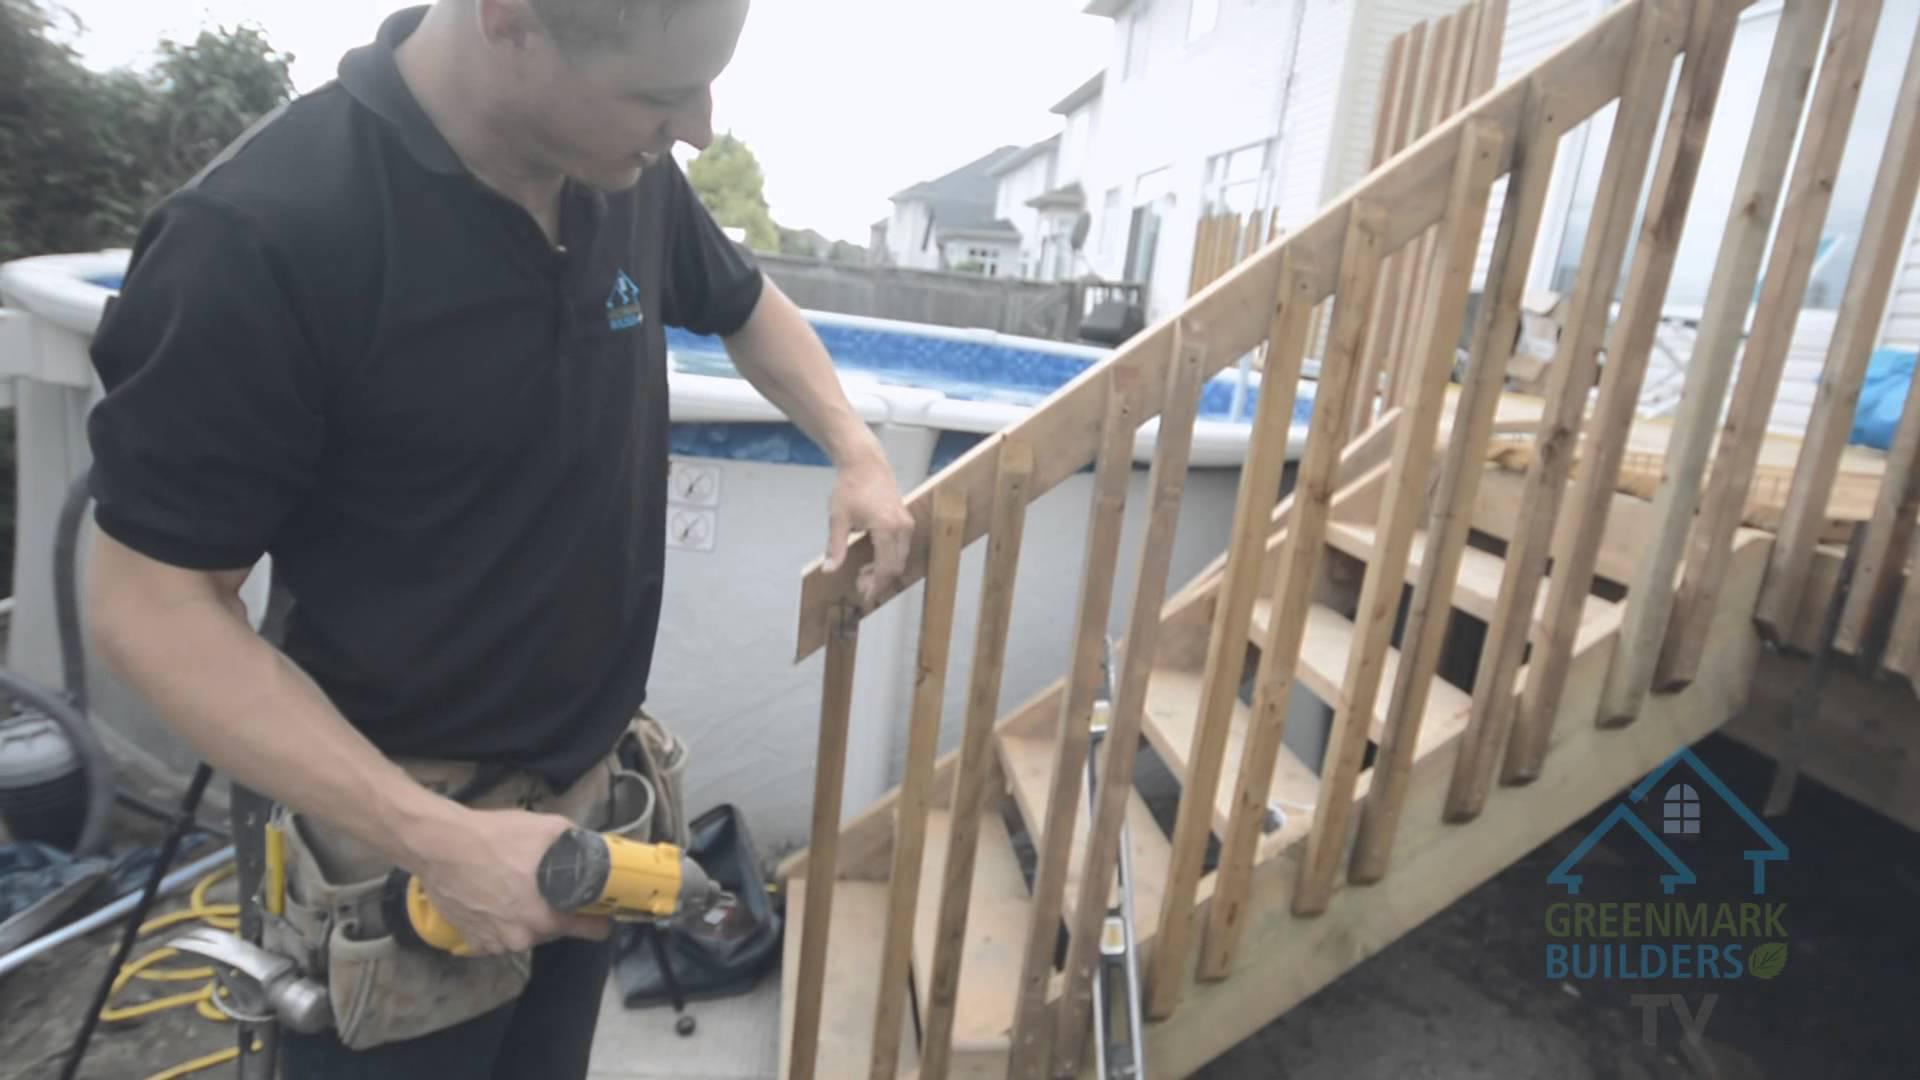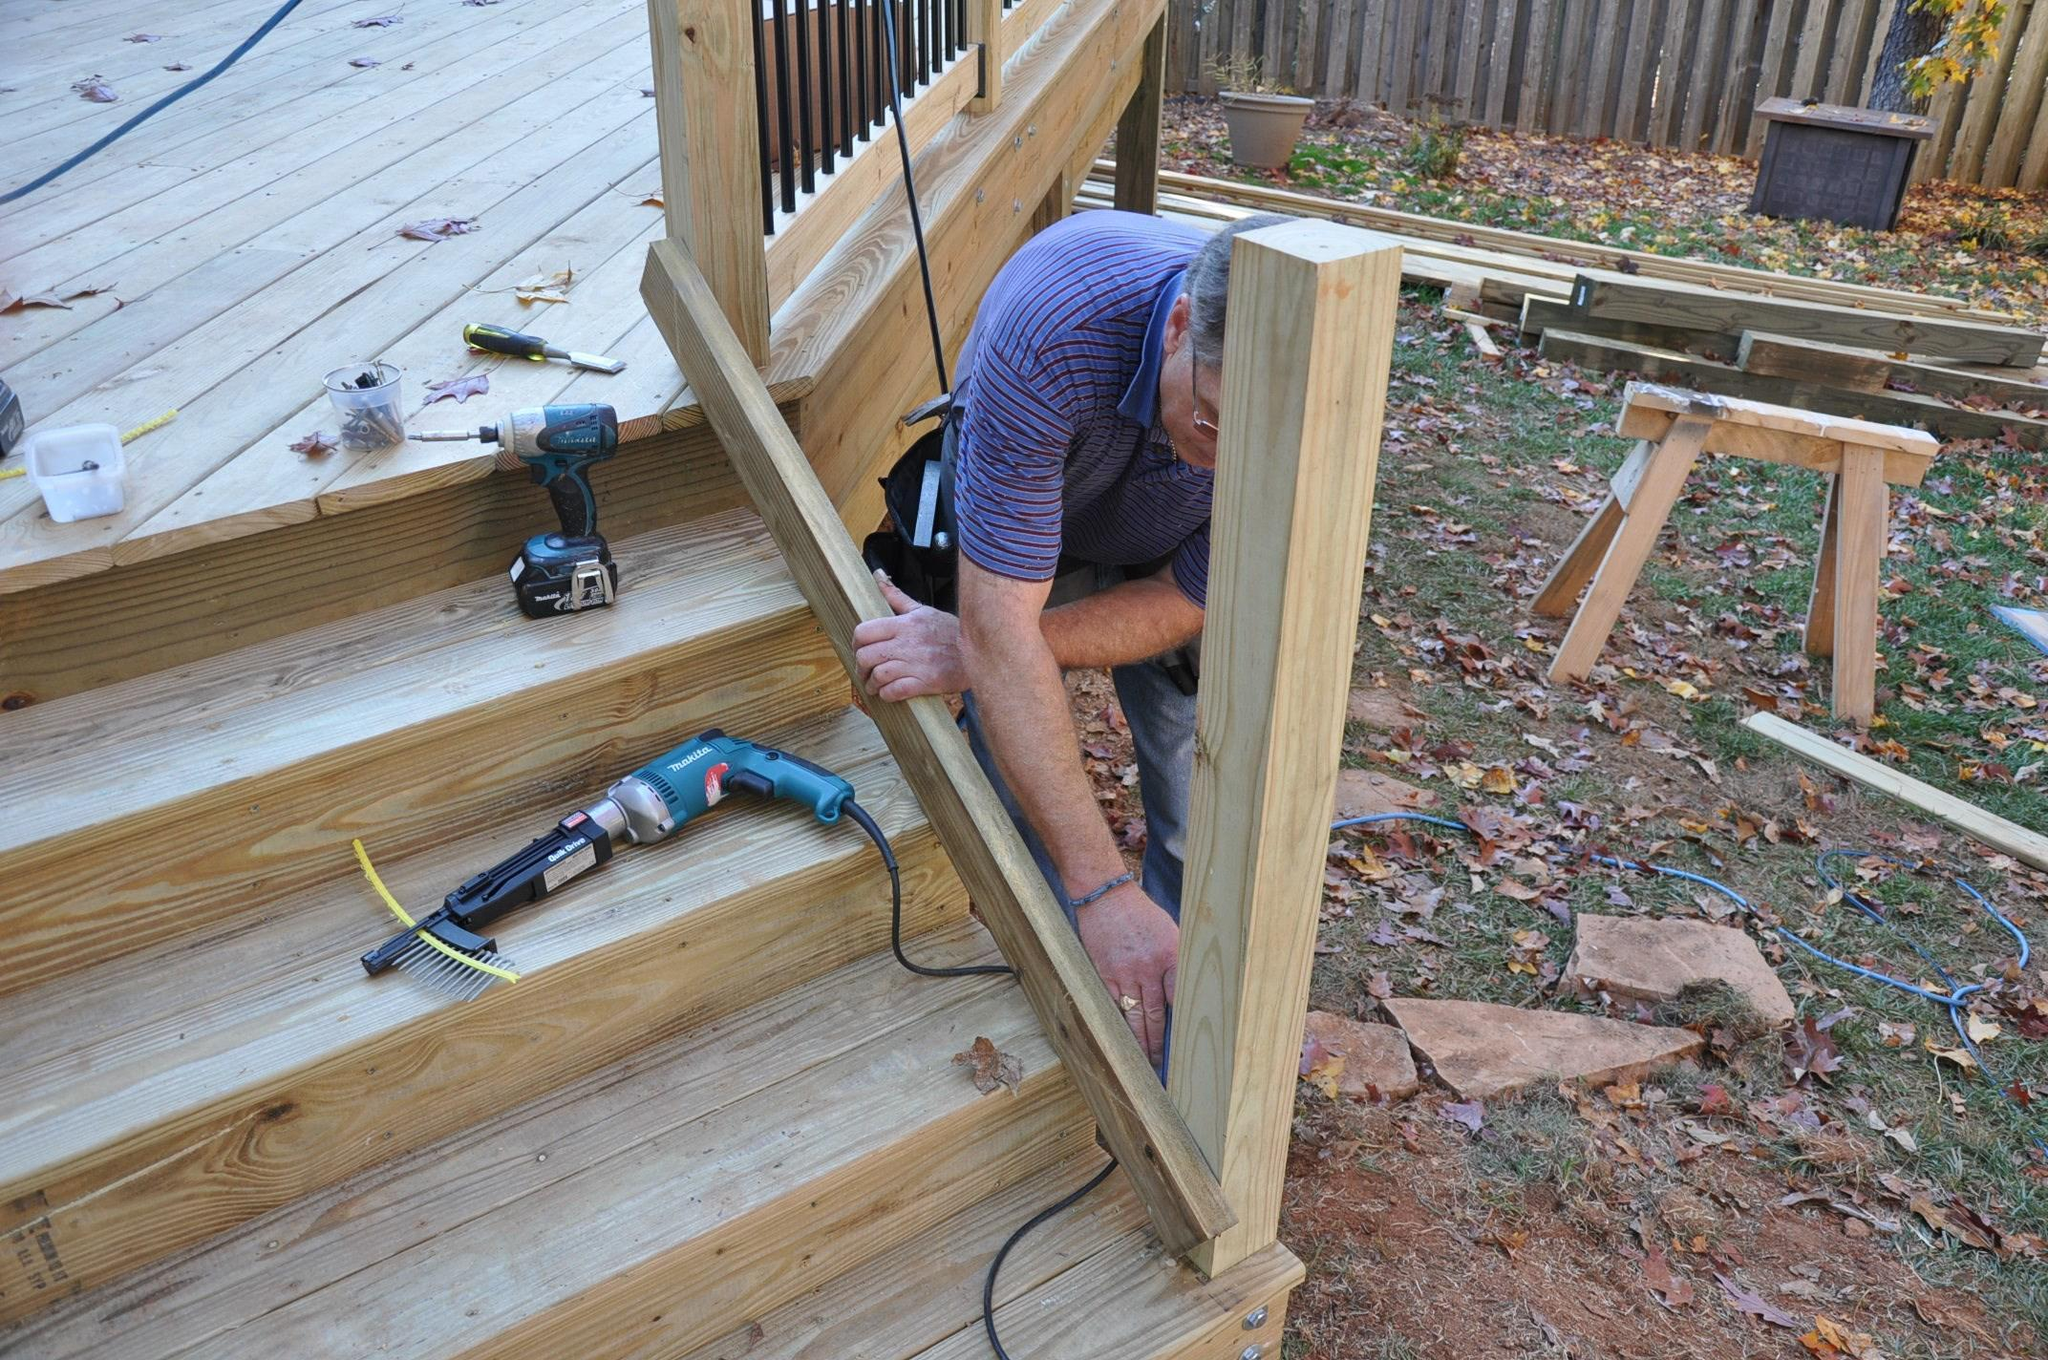The first image is the image on the left, the second image is the image on the right. For the images displayed, is the sentence "The left image contains one human doing carpentry." factually correct? Answer yes or no. Yes. The first image is the image on the left, the second image is the image on the right. For the images displayed, is the sentence "In one image, a wooden deck with ballustrade and set of stairs is outside the double doors of a house." factually correct? Answer yes or no. No. 